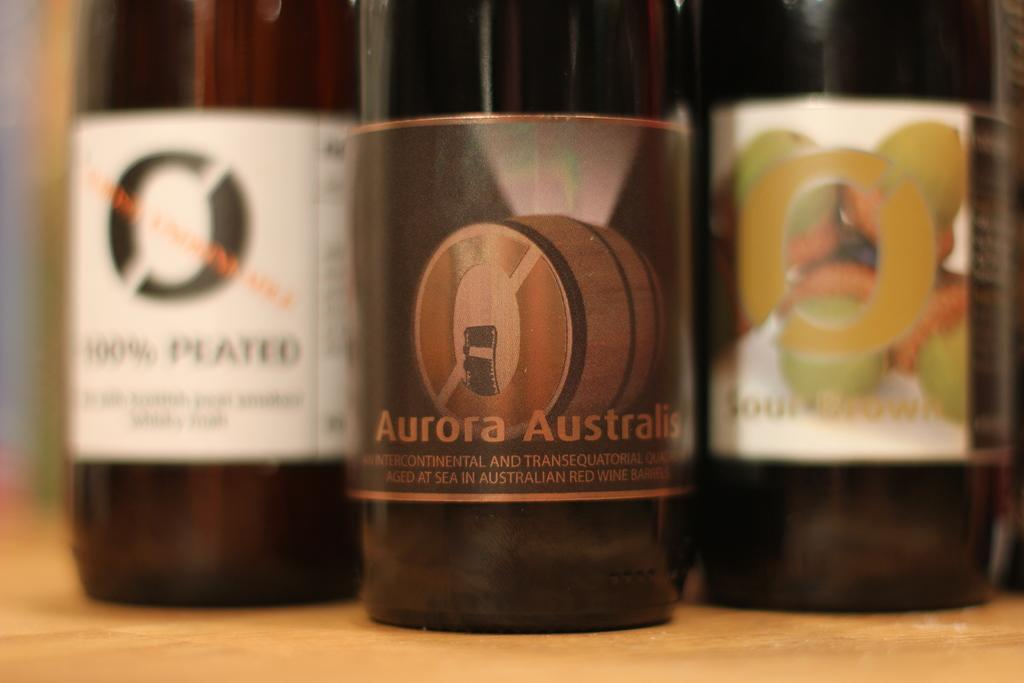<image>
Relay a brief, clear account of the picture shown. Three bottles of alcohol with one pushed to the front that has a label that says Aurora Australis 